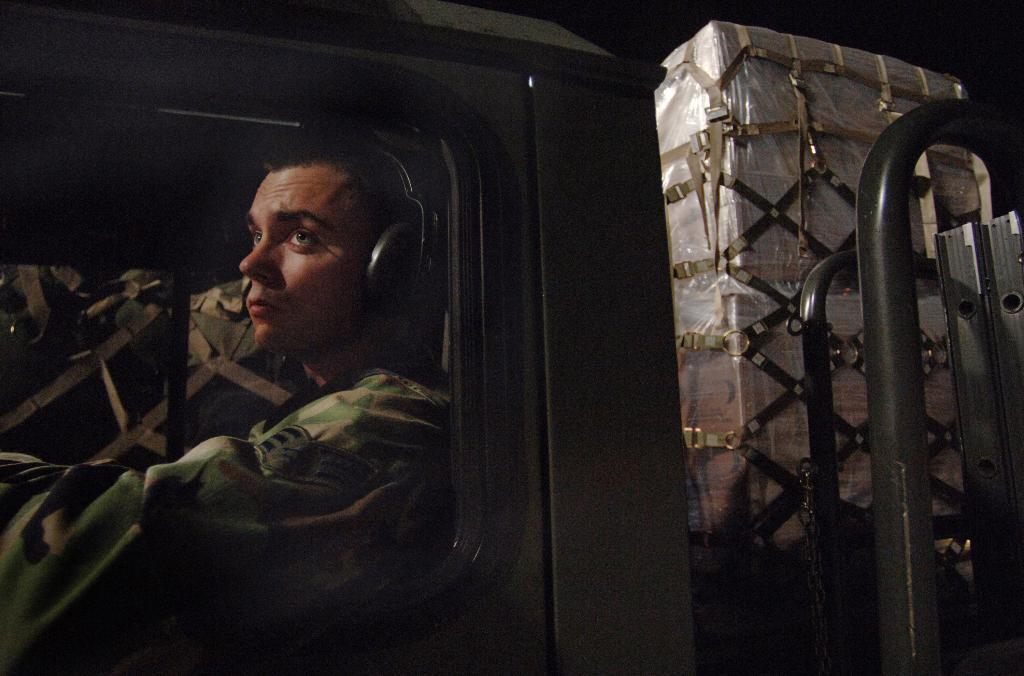Who is present in the image? There is a man in the image. Where is the man located in the image? The man is on the left side of the image. What is the man wearing? The man is wearing an army dress. What can be seen on the right side of the image? There are goods packed with a plastic cover in the image. What type of ant can be seen interacting with the goods in the image? There are no ants present in the image; it features a man wearing an army dress and goods packed with a plastic cover. What type of art is displayed on the man's uniform in the image? The man's uniform is an army dress, and there is no art displayed on it in the image. 